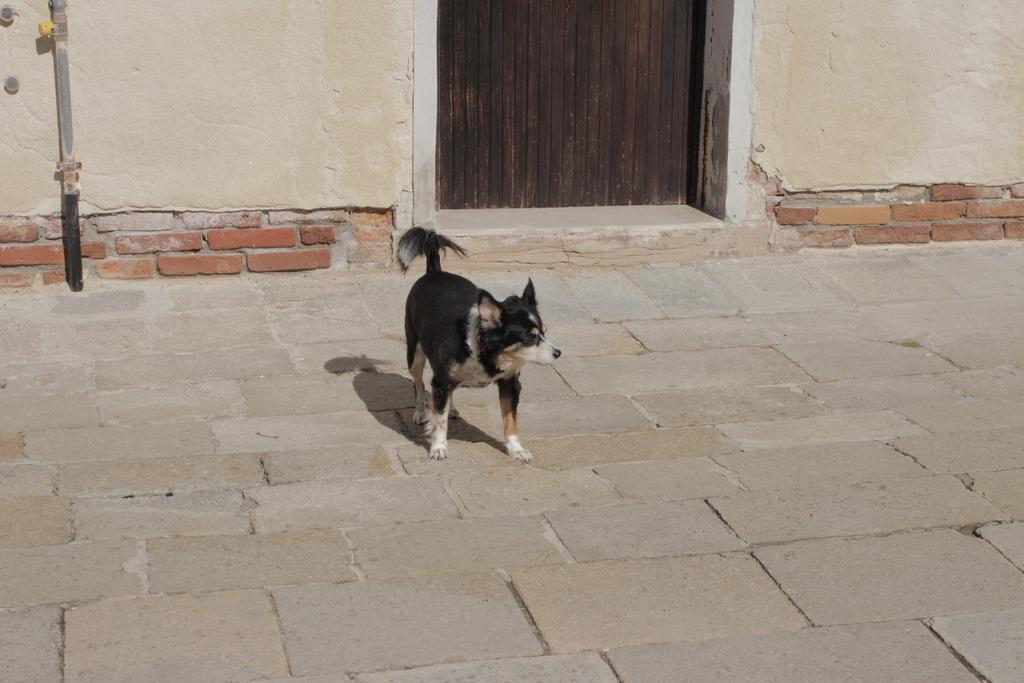Please provide a concise description of this image. In this image we can see a dog standing and we can also see a wooden door, pole and walls. 